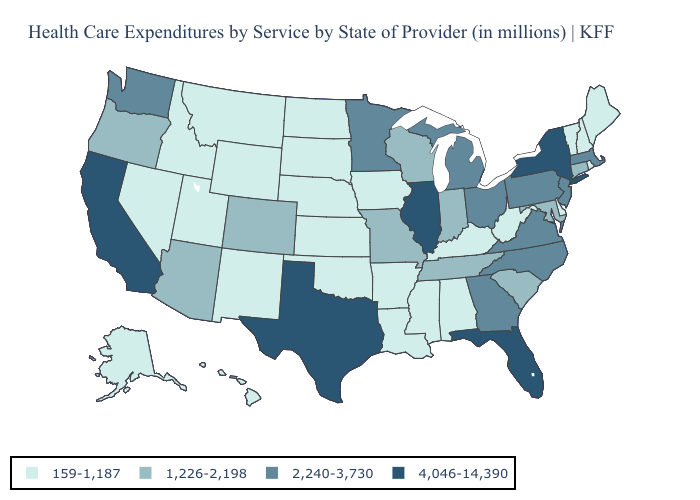Which states have the lowest value in the South?
Give a very brief answer. Alabama, Arkansas, Delaware, Kentucky, Louisiana, Mississippi, Oklahoma, West Virginia. Name the states that have a value in the range 2,240-3,730?
Write a very short answer. Georgia, Massachusetts, Michigan, Minnesota, New Jersey, North Carolina, Ohio, Pennsylvania, Virginia, Washington. Name the states that have a value in the range 159-1,187?
Concise answer only. Alabama, Alaska, Arkansas, Delaware, Hawaii, Idaho, Iowa, Kansas, Kentucky, Louisiana, Maine, Mississippi, Montana, Nebraska, Nevada, New Hampshire, New Mexico, North Dakota, Oklahoma, Rhode Island, South Dakota, Utah, Vermont, West Virginia, Wyoming. Does Georgia have a lower value than Texas?
Keep it brief. Yes. What is the value of North Dakota?
Write a very short answer. 159-1,187. Does Maryland have the lowest value in the South?
Quick response, please. No. Does Nebraska have the lowest value in the MidWest?
Short answer required. Yes. Among the states that border California , does Nevada have the lowest value?
Answer briefly. Yes. What is the lowest value in the USA?
Keep it brief. 159-1,187. Name the states that have a value in the range 4,046-14,390?
Quick response, please. California, Florida, Illinois, New York, Texas. Name the states that have a value in the range 2,240-3,730?
Concise answer only. Georgia, Massachusetts, Michigan, Minnesota, New Jersey, North Carolina, Ohio, Pennsylvania, Virginia, Washington. Among the states that border Massachusetts , does New York have the lowest value?
Concise answer only. No. Does the map have missing data?
Answer briefly. No. Which states have the lowest value in the South?
Concise answer only. Alabama, Arkansas, Delaware, Kentucky, Louisiana, Mississippi, Oklahoma, West Virginia. Does the map have missing data?
Be succinct. No. 